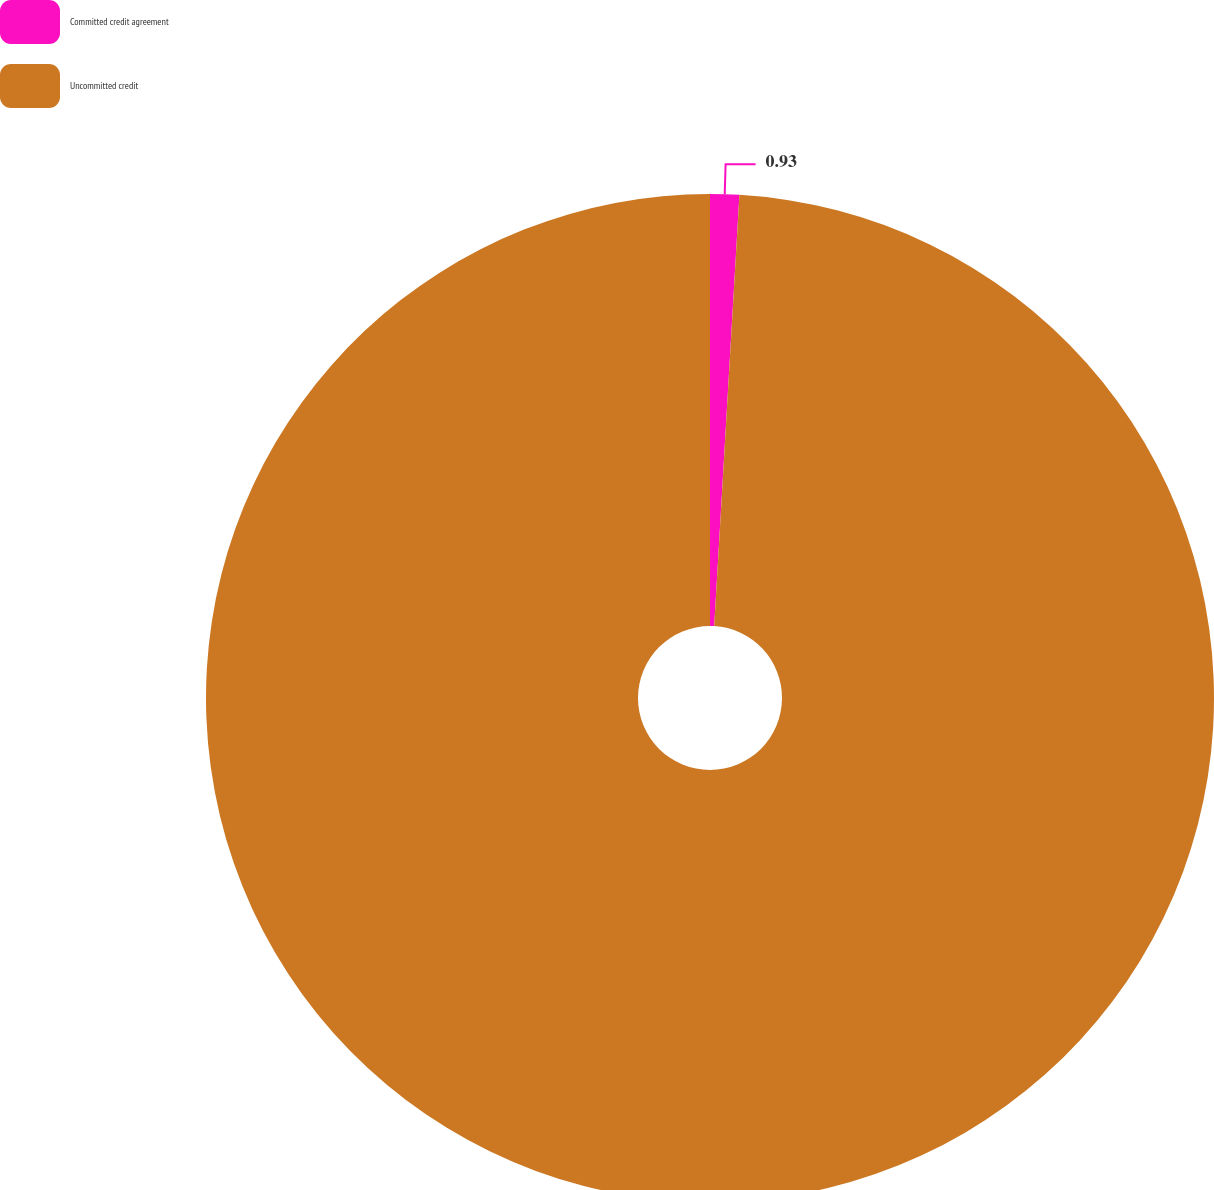Convert chart. <chart><loc_0><loc_0><loc_500><loc_500><pie_chart><fcel>Committed credit agreement<fcel>Uncommitted credit<nl><fcel>0.93%<fcel>99.07%<nl></chart> 